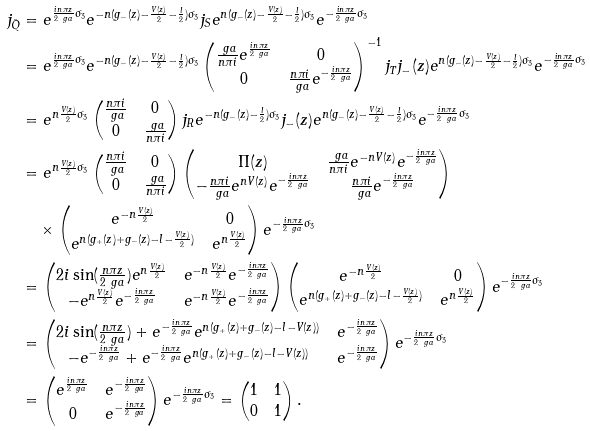Convert formula to latex. <formula><loc_0><loc_0><loc_500><loc_500>j _ { \tilde { Q } } & = e ^ { \frac { i n \pi z } { 2 \ g a } \sigma _ { 3 } } e ^ { - n ( g _ { - } ( z ) - \frac { V ( z ) } { 2 } - \frac { l } { 2 } ) \sigma _ { 3 } } j _ { S } e ^ { n ( g _ { - } ( z ) - \frac { V ( z ) } { 2 } - \frac { l } { 2 } ) \sigma _ { 3 } } e ^ { - \frac { i n \pi z } { 2 \ g a } \sigma _ { 3 } } \\ & = e ^ { \frac { i n \pi z } { 2 \ g a } \sigma _ { 3 } } e ^ { - n ( g _ { - } ( z ) - \frac { V ( z ) } { 2 } - \frac { l } { 2 } ) \sigma _ { 3 } } \begin{pmatrix} \frac { \ g a } { n \pi i } e ^ { \frac { i n \pi z } { 2 \ g a } } & 0 \\ 0 & \frac { n \pi i } { \ g a } e ^ { - \frac { i n \pi z } { 2 \ g a } } \end{pmatrix} ^ { - 1 } j _ { T } j _ { - } ( z ) e ^ { n ( g _ { - } ( z ) - \frac { V ( z ) } { 2 } - \frac { l } { 2 } ) \sigma _ { 3 } } e ^ { - \frac { i n \pi z } { 2 \ g a } \sigma _ { 3 } } \\ & = e ^ { n \frac { V ( z ) } { 2 } \sigma _ { 3 } } \begin{pmatrix} \frac { n \pi i } { \ g a } & 0 \\ 0 & \frac { \ g a } { n \pi i } \end{pmatrix} j _ { R } e ^ { - n ( g _ { - } ( z ) - \frac { l } { 2 } ) \sigma _ { 3 } } j _ { - } ( z ) e ^ { n ( g _ { - } ( z ) - \frac { V ( z ) } { 2 } - \frac { l } { 2 } ) \sigma _ { 3 } } e ^ { - \frac { i n \pi z } { 2 \ g a } \sigma _ { 3 } } \\ & = e ^ { n \frac { V ( z ) } { 2 } \sigma _ { 3 } } \begin{pmatrix} \frac { n \pi i } { \ g a } & 0 \\ 0 & \frac { \ g a } { n \pi i } \end{pmatrix} \begin{pmatrix} \Pi ( z ) & \frac { \ g a } { n \pi i } e ^ { - n V ( z ) } e ^ { - \frac { i n \pi z } { 2 \ g a } } \\ - \frac { n \pi i } { \ g a } e ^ { n V ( z ) } e ^ { - \frac { i n \pi z } { 2 \ g a } } & \frac { n \pi i } { \ g a } e ^ { - \frac { i n \pi z } { 2 \ g a } } \end{pmatrix} \\ & \quad \times \begin{pmatrix} e ^ { - n \frac { V ( z ) } { 2 } } & 0 \\ e ^ { n ( g _ { + } ( z ) + g _ { - } ( z ) - l - \frac { V ( z ) } { 2 } ) } & e ^ { n \frac { V ( z ) } { 2 } } \end{pmatrix} e ^ { - \frac { i n \pi z } { 2 \ g a } \sigma _ { 3 } } \\ & = \begin{pmatrix} 2 i \sin ( \frac { n \pi z } { 2 \ g a } ) e ^ { n \frac { V ( z ) } { 2 } } & e ^ { - n \frac { V ( z ) } { 2 } } e ^ { - \frac { i n \pi z } { 2 \ g a } } \\ - e ^ { n \frac { V ( z ) } { 2 } } e ^ { - \frac { i n \pi z } { 2 \ g a } } & e ^ { - n \frac { V ( z ) } { 2 } } e ^ { - \frac { i n \pi z } { 2 \ g a } } \end{pmatrix} \begin{pmatrix} e ^ { - n \frac { V ( z ) } { 2 } } & 0 \\ e ^ { n ( g _ { + } ( z ) + g _ { - } ( z ) - l - \frac { V ( z ) } { 2 } ) } & e ^ { n \frac { V ( z ) } { 2 } } \end{pmatrix} e ^ { - \frac { i n \pi z } { 2 \ g a } \sigma _ { 3 } } \\ & = \begin{pmatrix} 2 i \sin ( \frac { n \pi z } { 2 \ g a } ) + e ^ { - \frac { i n \pi z } { 2 \ g a } } e ^ { n ( g _ { + } ( z ) + g _ { - } ( z ) - l - V ( z ) ) } & e ^ { - \frac { i n \pi z } { 2 \ g a } } \\ - e ^ { - \frac { i n \pi z } { 2 \ g a } } + e ^ { - \frac { i n \pi z } { 2 \ g a } } e ^ { n ( g _ { + } ( z ) + g _ { - } ( z ) - l - V ( z ) ) } & e ^ { - \frac { i n \pi z } { 2 \ g a } } \end{pmatrix} e ^ { - \frac { i n \pi z } { 2 \ g a } \sigma _ { 3 } } \\ & = \begin{pmatrix} e ^ { \frac { i n \pi z } { 2 \ g a } } & e ^ { - \frac { i n \pi z } { 2 \ g a } } \\ 0 & e ^ { - \frac { i n \pi z } { 2 \ g a } } \end{pmatrix} e ^ { - \frac { i n \pi z } { 2 \ g a } \sigma _ { 3 } } = \begin{pmatrix} 1 & 1 \\ 0 & 1 \end{pmatrix} .</formula> 